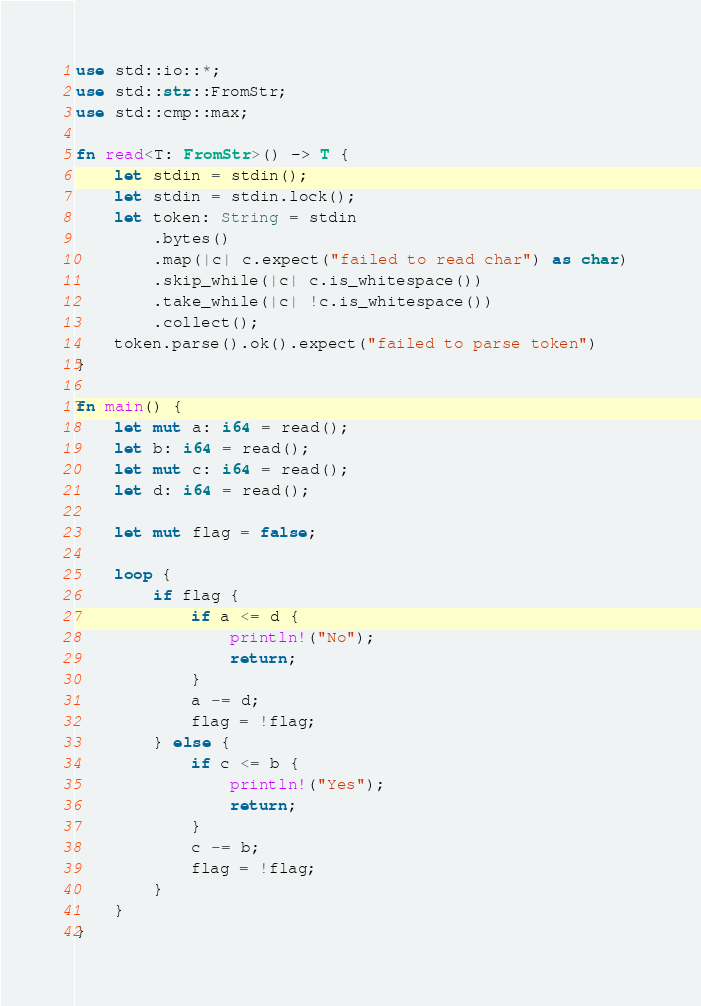Convert code to text. <code><loc_0><loc_0><loc_500><loc_500><_Rust_>use std::io::*;
use std::str::FromStr;
use std::cmp::max;

fn read<T: FromStr>() -> T {
    let stdin = stdin();
    let stdin = stdin.lock();
    let token: String = stdin
        .bytes()
        .map(|c| c.expect("failed to read char") as char) 
        .skip_while(|c| c.is_whitespace())
        .take_while(|c| !c.is_whitespace())
        .collect();
    token.parse().ok().expect("failed to parse token")
}

fn main() {
    let mut a: i64 = read();
    let b: i64 = read();
    let mut c: i64 = read();
    let d: i64 = read();

    let mut flag = false;

    loop {
        if flag {
            if a <= d {
                println!("No");
                return;
            }
            a -= d;
            flag = !flag;
        } else {
            if c <= b {
                println!("Yes");
                return;
            }
            c -= b;
            flag = !flag;
        }
    }
}
</code> 